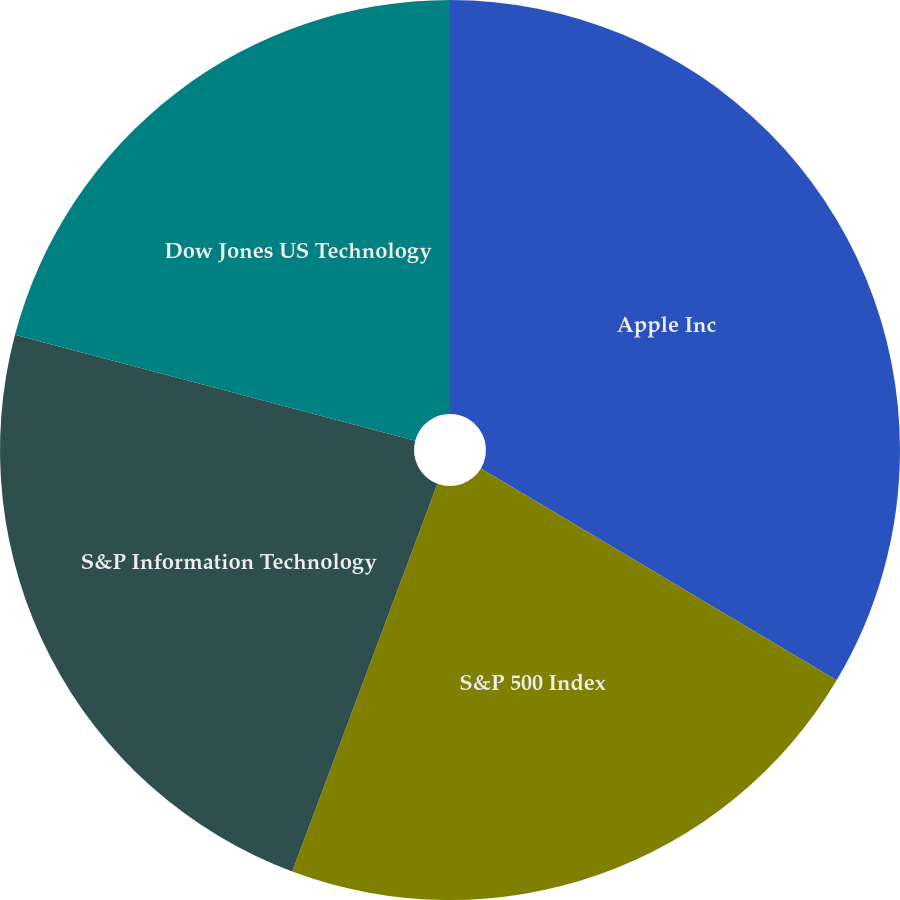<chart> <loc_0><loc_0><loc_500><loc_500><pie_chart><fcel>Apple Inc<fcel>S&P 500 Index<fcel>S&P Information Technology<fcel>Dow Jones US Technology<nl><fcel>33.55%<fcel>22.15%<fcel>23.42%<fcel>20.88%<nl></chart> 